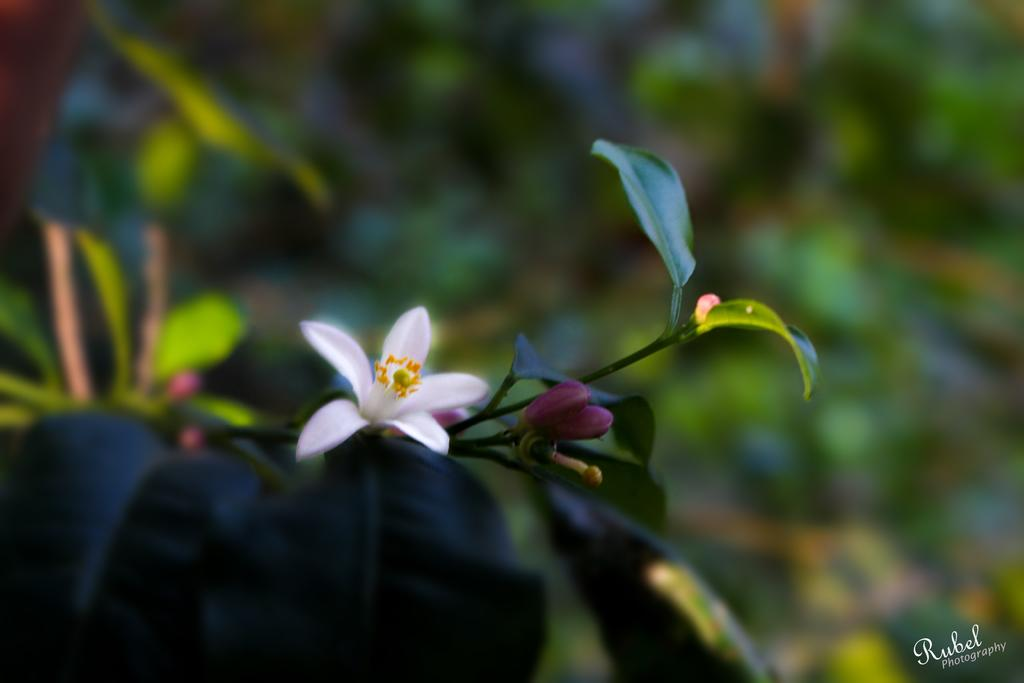What type of plant is in the image? There is a white flower plant in the image. What stage of growth are the flowers on the plant? The plant has buds. Can you describe the background of the image? The background of the image is blurred. What type of advertisement is displayed on the door in the image? There is no door or advertisement present in the image; it features a white flower plant with buds against a blurred background. 